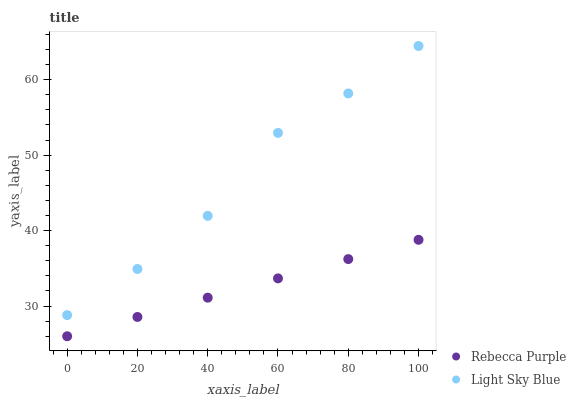Does Rebecca Purple have the minimum area under the curve?
Answer yes or no. Yes. Does Light Sky Blue have the maximum area under the curve?
Answer yes or no. Yes. Does Rebecca Purple have the maximum area under the curve?
Answer yes or no. No. Is Rebecca Purple the smoothest?
Answer yes or no. Yes. Is Light Sky Blue the roughest?
Answer yes or no. Yes. Is Rebecca Purple the roughest?
Answer yes or no. No. Does Rebecca Purple have the lowest value?
Answer yes or no. Yes. Does Light Sky Blue have the highest value?
Answer yes or no. Yes. Does Rebecca Purple have the highest value?
Answer yes or no. No. Is Rebecca Purple less than Light Sky Blue?
Answer yes or no. Yes. Is Light Sky Blue greater than Rebecca Purple?
Answer yes or no. Yes. Does Rebecca Purple intersect Light Sky Blue?
Answer yes or no. No. 